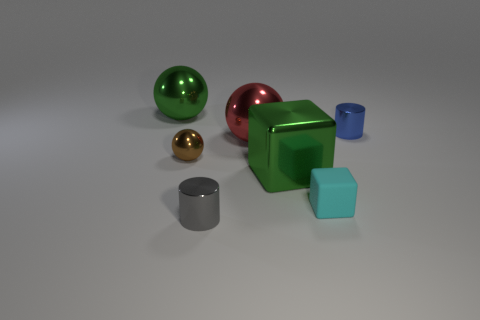How many green metallic spheres have the same size as the cyan rubber object?
Your answer should be compact. 0. How many other objects are there of the same color as the metal block?
Provide a succinct answer. 1. There is a big green metallic object that is to the left of the small gray metal cylinder; does it have the same shape as the small brown shiny object left of the small cube?
Provide a short and direct response. Yes. What shape is the brown shiny object that is the same size as the gray metallic cylinder?
Your answer should be compact. Sphere. Are there an equal number of large green shiny blocks that are behind the matte cube and metal objects on the right side of the green ball?
Your answer should be very brief. No. Are there any other things that are the same shape as the big red shiny object?
Your answer should be compact. Yes. Do the cylinder that is right of the green cube and the large red thing have the same material?
Provide a short and direct response. Yes. There is a red thing that is the same size as the green block; what material is it?
Offer a very short reply. Metal. What number of other things are the same material as the small blue cylinder?
Offer a terse response. 5. Is the size of the blue cylinder the same as the metallic ball behind the big red shiny object?
Keep it short and to the point. No. 